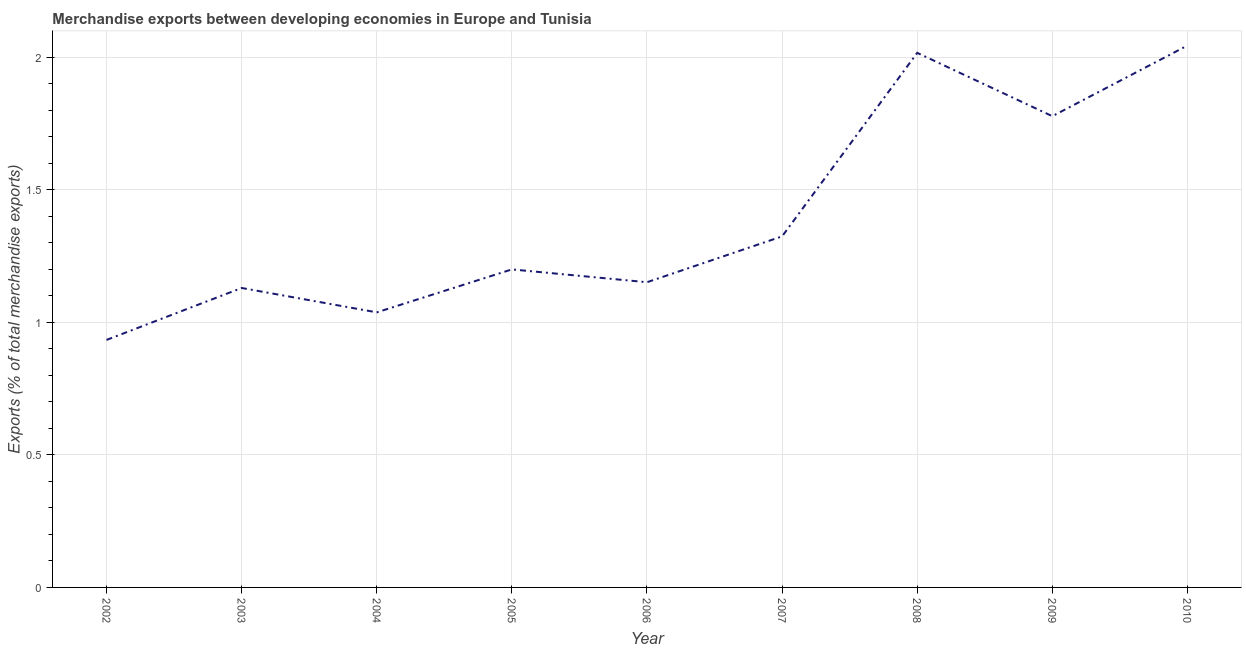What is the merchandise exports in 2008?
Give a very brief answer. 2.02. Across all years, what is the maximum merchandise exports?
Keep it short and to the point. 2.04. Across all years, what is the minimum merchandise exports?
Provide a short and direct response. 0.93. What is the sum of the merchandise exports?
Give a very brief answer. 12.61. What is the difference between the merchandise exports in 2003 and 2008?
Your answer should be very brief. -0.89. What is the average merchandise exports per year?
Your answer should be compact. 1.4. What is the median merchandise exports?
Provide a succinct answer. 1.2. Do a majority of the years between 2006 and 2003 (inclusive) have merchandise exports greater than 1.1 %?
Provide a succinct answer. Yes. What is the ratio of the merchandise exports in 2003 to that in 2010?
Provide a succinct answer. 0.55. Is the merchandise exports in 2002 less than that in 2005?
Ensure brevity in your answer.  Yes. What is the difference between the highest and the second highest merchandise exports?
Give a very brief answer. 0.03. Is the sum of the merchandise exports in 2002 and 2010 greater than the maximum merchandise exports across all years?
Ensure brevity in your answer.  Yes. What is the difference between the highest and the lowest merchandise exports?
Ensure brevity in your answer.  1.11. Does the merchandise exports monotonically increase over the years?
Provide a succinct answer. No. How many lines are there?
Give a very brief answer. 1. Are the values on the major ticks of Y-axis written in scientific E-notation?
Provide a short and direct response. No. What is the title of the graph?
Provide a short and direct response. Merchandise exports between developing economies in Europe and Tunisia. What is the label or title of the Y-axis?
Your answer should be very brief. Exports (% of total merchandise exports). What is the Exports (% of total merchandise exports) in 2002?
Your answer should be very brief. 0.93. What is the Exports (% of total merchandise exports) of 2003?
Keep it short and to the point. 1.13. What is the Exports (% of total merchandise exports) in 2004?
Offer a terse response. 1.04. What is the Exports (% of total merchandise exports) of 2005?
Give a very brief answer. 1.2. What is the Exports (% of total merchandise exports) in 2006?
Offer a terse response. 1.15. What is the Exports (% of total merchandise exports) in 2007?
Make the answer very short. 1.32. What is the Exports (% of total merchandise exports) of 2008?
Your answer should be compact. 2.02. What is the Exports (% of total merchandise exports) in 2009?
Your answer should be very brief. 1.78. What is the Exports (% of total merchandise exports) of 2010?
Offer a very short reply. 2.04. What is the difference between the Exports (% of total merchandise exports) in 2002 and 2003?
Your answer should be very brief. -0.2. What is the difference between the Exports (% of total merchandise exports) in 2002 and 2004?
Give a very brief answer. -0.1. What is the difference between the Exports (% of total merchandise exports) in 2002 and 2005?
Keep it short and to the point. -0.27. What is the difference between the Exports (% of total merchandise exports) in 2002 and 2006?
Your answer should be very brief. -0.22. What is the difference between the Exports (% of total merchandise exports) in 2002 and 2007?
Offer a terse response. -0.39. What is the difference between the Exports (% of total merchandise exports) in 2002 and 2008?
Your answer should be very brief. -1.08. What is the difference between the Exports (% of total merchandise exports) in 2002 and 2009?
Make the answer very short. -0.84. What is the difference between the Exports (% of total merchandise exports) in 2002 and 2010?
Your answer should be very brief. -1.11. What is the difference between the Exports (% of total merchandise exports) in 2003 and 2004?
Keep it short and to the point. 0.09. What is the difference between the Exports (% of total merchandise exports) in 2003 and 2005?
Your response must be concise. -0.07. What is the difference between the Exports (% of total merchandise exports) in 2003 and 2006?
Provide a succinct answer. -0.02. What is the difference between the Exports (% of total merchandise exports) in 2003 and 2007?
Provide a succinct answer. -0.19. What is the difference between the Exports (% of total merchandise exports) in 2003 and 2008?
Your answer should be very brief. -0.89. What is the difference between the Exports (% of total merchandise exports) in 2003 and 2009?
Provide a succinct answer. -0.65. What is the difference between the Exports (% of total merchandise exports) in 2003 and 2010?
Ensure brevity in your answer.  -0.91. What is the difference between the Exports (% of total merchandise exports) in 2004 and 2005?
Offer a very short reply. -0.16. What is the difference between the Exports (% of total merchandise exports) in 2004 and 2006?
Your response must be concise. -0.11. What is the difference between the Exports (% of total merchandise exports) in 2004 and 2007?
Offer a terse response. -0.29. What is the difference between the Exports (% of total merchandise exports) in 2004 and 2008?
Provide a succinct answer. -0.98. What is the difference between the Exports (% of total merchandise exports) in 2004 and 2009?
Offer a terse response. -0.74. What is the difference between the Exports (% of total merchandise exports) in 2004 and 2010?
Provide a short and direct response. -1.01. What is the difference between the Exports (% of total merchandise exports) in 2005 and 2006?
Keep it short and to the point. 0.05. What is the difference between the Exports (% of total merchandise exports) in 2005 and 2007?
Provide a succinct answer. -0.12. What is the difference between the Exports (% of total merchandise exports) in 2005 and 2008?
Keep it short and to the point. -0.82. What is the difference between the Exports (% of total merchandise exports) in 2005 and 2009?
Ensure brevity in your answer.  -0.58. What is the difference between the Exports (% of total merchandise exports) in 2005 and 2010?
Offer a terse response. -0.84. What is the difference between the Exports (% of total merchandise exports) in 2006 and 2007?
Provide a succinct answer. -0.17. What is the difference between the Exports (% of total merchandise exports) in 2006 and 2008?
Keep it short and to the point. -0.86. What is the difference between the Exports (% of total merchandise exports) in 2006 and 2009?
Provide a short and direct response. -0.63. What is the difference between the Exports (% of total merchandise exports) in 2006 and 2010?
Your response must be concise. -0.89. What is the difference between the Exports (% of total merchandise exports) in 2007 and 2008?
Your response must be concise. -0.69. What is the difference between the Exports (% of total merchandise exports) in 2007 and 2009?
Make the answer very short. -0.45. What is the difference between the Exports (% of total merchandise exports) in 2007 and 2010?
Offer a very short reply. -0.72. What is the difference between the Exports (% of total merchandise exports) in 2008 and 2009?
Ensure brevity in your answer.  0.24. What is the difference between the Exports (% of total merchandise exports) in 2008 and 2010?
Provide a short and direct response. -0.03. What is the difference between the Exports (% of total merchandise exports) in 2009 and 2010?
Ensure brevity in your answer.  -0.27. What is the ratio of the Exports (% of total merchandise exports) in 2002 to that in 2003?
Give a very brief answer. 0.83. What is the ratio of the Exports (% of total merchandise exports) in 2002 to that in 2004?
Give a very brief answer. 0.9. What is the ratio of the Exports (% of total merchandise exports) in 2002 to that in 2005?
Offer a very short reply. 0.78. What is the ratio of the Exports (% of total merchandise exports) in 2002 to that in 2006?
Provide a succinct answer. 0.81. What is the ratio of the Exports (% of total merchandise exports) in 2002 to that in 2007?
Ensure brevity in your answer.  0.7. What is the ratio of the Exports (% of total merchandise exports) in 2002 to that in 2008?
Give a very brief answer. 0.46. What is the ratio of the Exports (% of total merchandise exports) in 2002 to that in 2009?
Offer a very short reply. 0.53. What is the ratio of the Exports (% of total merchandise exports) in 2002 to that in 2010?
Offer a terse response. 0.46. What is the ratio of the Exports (% of total merchandise exports) in 2003 to that in 2004?
Give a very brief answer. 1.09. What is the ratio of the Exports (% of total merchandise exports) in 2003 to that in 2005?
Offer a very short reply. 0.94. What is the ratio of the Exports (% of total merchandise exports) in 2003 to that in 2007?
Give a very brief answer. 0.85. What is the ratio of the Exports (% of total merchandise exports) in 2003 to that in 2008?
Offer a terse response. 0.56. What is the ratio of the Exports (% of total merchandise exports) in 2003 to that in 2009?
Your answer should be compact. 0.64. What is the ratio of the Exports (% of total merchandise exports) in 2003 to that in 2010?
Offer a very short reply. 0.55. What is the ratio of the Exports (% of total merchandise exports) in 2004 to that in 2005?
Make the answer very short. 0.86. What is the ratio of the Exports (% of total merchandise exports) in 2004 to that in 2006?
Give a very brief answer. 0.9. What is the ratio of the Exports (% of total merchandise exports) in 2004 to that in 2007?
Keep it short and to the point. 0.78. What is the ratio of the Exports (% of total merchandise exports) in 2004 to that in 2008?
Provide a succinct answer. 0.52. What is the ratio of the Exports (% of total merchandise exports) in 2004 to that in 2009?
Offer a terse response. 0.58. What is the ratio of the Exports (% of total merchandise exports) in 2004 to that in 2010?
Ensure brevity in your answer.  0.51. What is the ratio of the Exports (% of total merchandise exports) in 2005 to that in 2006?
Provide a short and direct response. 1.04. What is the ratio of the Exports (% of total merchandise exports) in 2005 to that in 2007?
Provide a short and direct response. 0.91. What is the ratio of the Exports (% of total merchandise exports) in 2005 to that in 2008?
Provide a short and direct response. 0.59. What is the ratio of the Exports (% of total merchandise exports) in 2005 to that in 2009?
Make the answer very short. 0.68. What is the ratio of the Exports (% of total merchandise exports) in 2005 to that in 2010?
Provide a short and direct response. 0.59. What is the ratio of the Exports (% of total merchandise exports) in 2006 to that in 2007?
Your response must be concise. 0.87. What is the ratio of the Exports (% of total merchandise exports) in 2006 to that in 2008?
Provide a succinct answer. 0.57. What is the ratio of the Exports (% of total merchandise exports) in 2006 to that in 2009?
Offer a very short reply. 0.65. What is the ratio of the Exports (% of total merchandise exports) in 2006 to that in 2010?
Ensure brevity in your answer.  0.56. What is the ratio of the Exports (% of total merchandise exports) in 2007 to that in 2008?
Make the answer very short. 0.66. What is the ratio of the Exports (% of total merchandise exports) in 2007 to that in 2009?
Keep it short and to the point. 0.74. What is the ratio of the Exports (% of total merchandise exports) in 2007 to that in 2010?
Offer a terse response. 0.65. What is the ratio of the Exports (% of total merchandise exports) in 2008 to that in 2009?
Give a very brief answer. 1.13. What is the ratio of the Exports (% of total merchandise exports) in 2008 to that in 2010?
Provide a short and direct response. 0.99. What is the ratio of the Exports (% of total merchandise exports) in 2009 to that in 2010?
Make the answer very short. 0.87. 